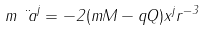<formula> <loc_0><loc_0><loc_500><loc_500>m \ddot { \ a } ^ { j } = - 2 ( m M - q Q ) x ^ { j } r ^ { - 3 }</formula> 